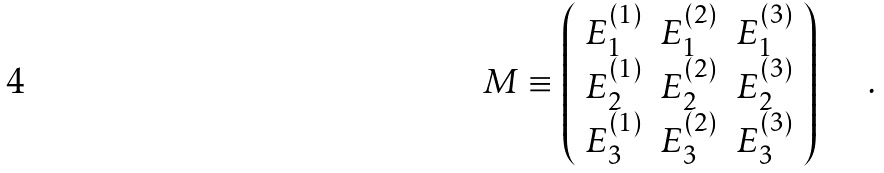<formula> <loc_0><loc_0><loc_500><loc_500>M \equiv \left ( \begin{array} { c c c } E _ { 1 } ^ { ( 1 ) } & E _ { 1 } ^ { ( 2 ) } & E _ { 1 } ^ { ( 3 ) } \\ E _ { 2 } ^ { ( 1 ) } & E _ { 2 } ^ { ( 2 ) } & E _ { 2 } ^ { ( 3 ) } \\ E _ { 3 } ^ { ( 1 ) } & E _ { 3 } ^ { ( 2 ) } & E _ { 3 } ^ { ( 3 ) } \end{array} \right ) \text { \quad . }</formula> 